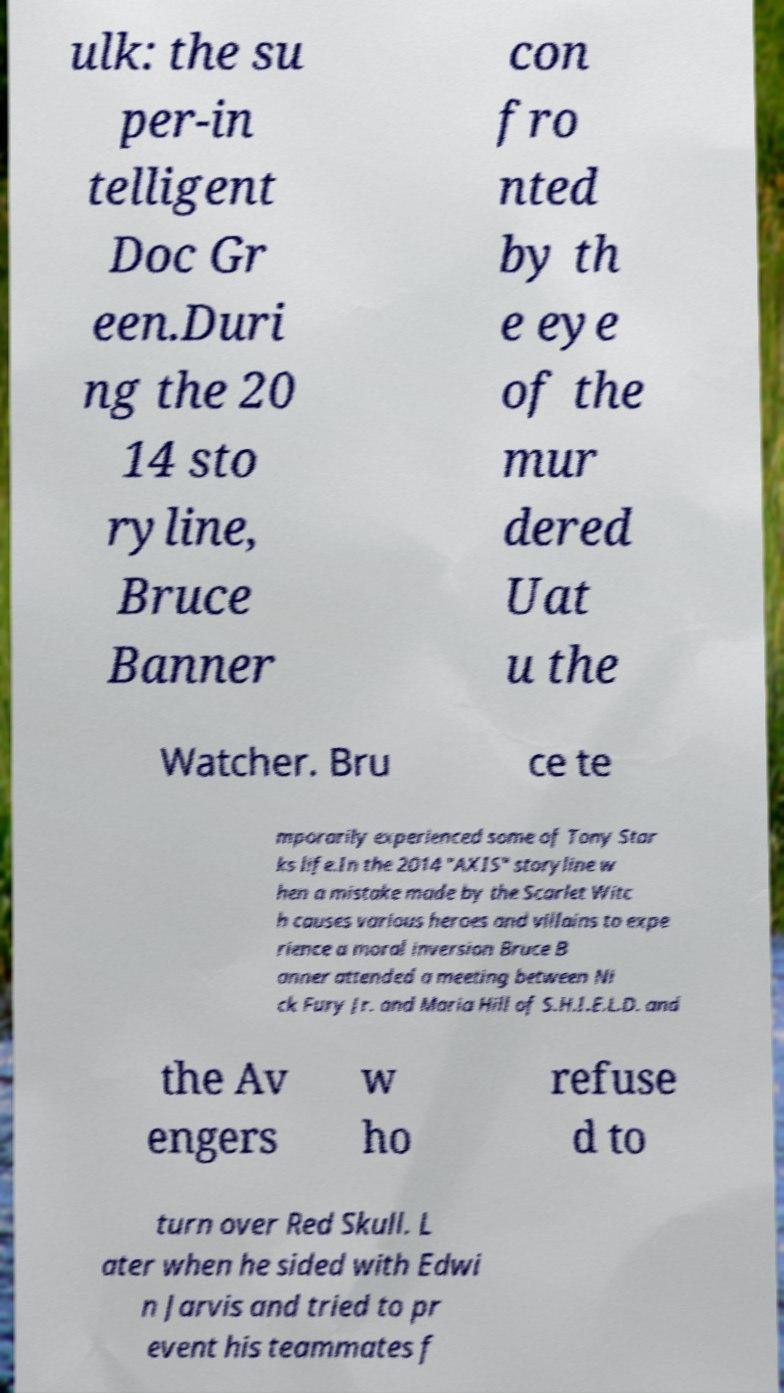Could you assist in decoding the text presented in this image and type it out clearly? ulk: the su per-in telligent Doc Gr een.Duri ng the 20 14 sto ryline, Bruce Banner con fro nted by th e eye of the mur dered Uat u the Watcher. Bru ce te mporarily experienced some of Tony Star ks life.In the 2014 "AXIS" storyline w hen a mistake made by the Scarlet Witc h causes various heroes and villains to expe rience a moral inversion Bruce B anner attended a meeting between Ni ck Fury Jr. and Maria Hill of S.H.I.E.L.D. and the Av engers w ho refuse d to turn over Red Skull. L ater when he sided with Edwi n Jarvis and tried to pr event his teammates f 